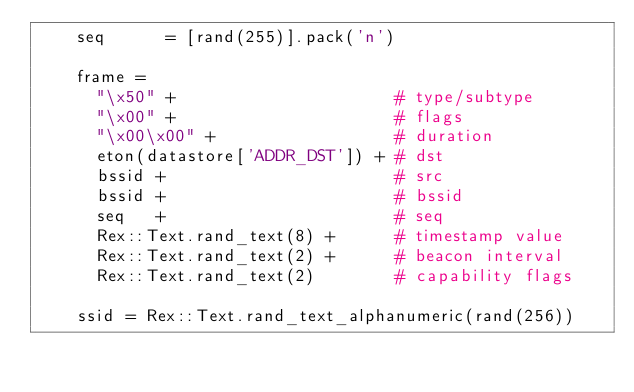<code> <loc_0><loc_0><loc_500><loc_500><_Ruby_>    seq      = [rand(255)].pack('n')

    frame =
      "\x50" +                      # type/subtype
      "\x00" +                      # flags
      "\x00\x00" +                  # duration
      eton(datastore['ADDR_DST']) + # dst
      bssid +                       # src
      bssid +                       # bssid
      seq   +                       # seq
      Rex::Text.rand_text(8) +      # timestamp value
      Rex::Text.rand_text(2) +      # beacon interval
      Rex::Text.rand_text(2)        # capability flags

    ssid = Rex::Text.rand_text_alphanumeric(rand(256))
</code> 